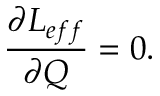<formula> <loc_0><loc_0><loc_500><loc_500>\frac { \partial L _ { e f f } } { \partial Q } = 0 .</formula> 